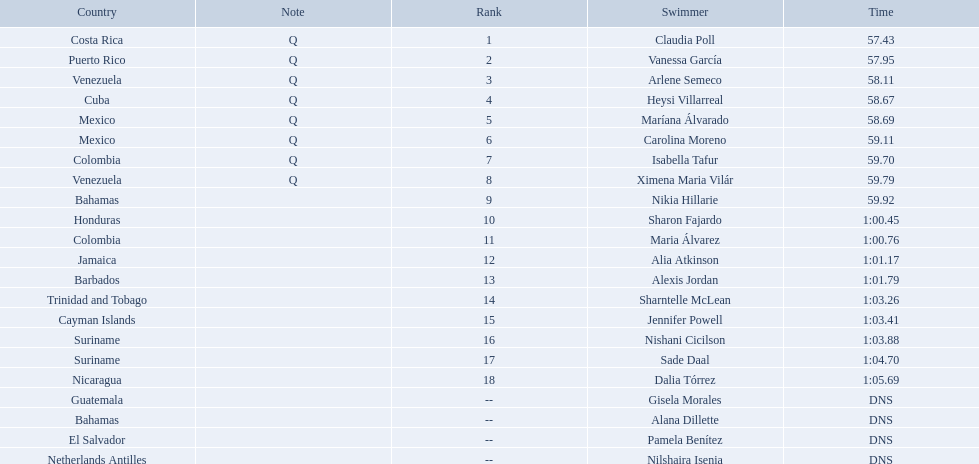Who were all of the swimmers in the women's 100 metre freestyle? Claudia Poll, Vanessa García, Arlene Semeco, Heysi Villarreal, Maríana Álvarado, Carolina Moreno, Isabella Tafur, Ximena Maria Vilár, Nikia Hillarie, Sharon Fajardo, Maria Álvarez, Alia Atkinson, Alexis Jordan, Sharntelle McLean, Jennifer Powell, Nishani Cicilson, Sade Daal, Dalia Tórrez, Gisela Morales, Alana Dillette, Pamela Benítez, Nilshaira Isenia. Where was each swimmer from? Costa Rica, Puerto Rico, Venezuela, Cuba, Mexico, Mexico, Colombia, Venezuela, Bahamas, Honduras, Colombia, Jamaica, Barbados, Trinidad and Tobago, Cayman Islands, Suriname, Suriname, Nicaragua, Guatemala, Bahamas, El Salvador, Netherlands Antilles. What were their ranks? 1, 2, 3, 4, 5, 6, 7, 8, 9, 10, 11, 12, 13, 14, 15, 16, 17, 18, --, --, --, --. Who was in the top eight? Claudia Poll, Vanessa García, Arlene Semeco, Heysi Villarreal, Maríana Álvarado, Carolina Moreno, Isabella Tafur, Ximena Maria Vilár. Of those swimmers, which one was from cuba? Heysi Villarreal. 